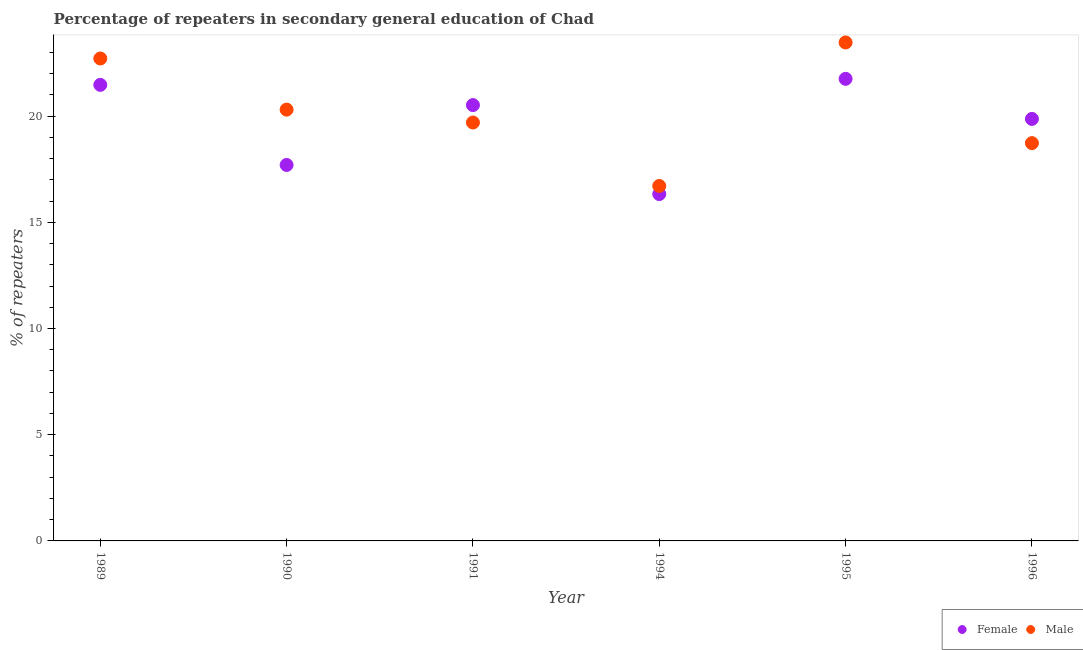How many different coloured dotlines are there?
Your answer should be very brief. 2. Is the number of dotlines equal to the number of legend labels?
Make the answer very short. Yes. What is the percentage of female repeaters in 1991?
Offer a terse response. 20.52. Across all years, what is the maximum percentage of male repeaters?
Your response must be concise. 23.47. Across all years, what is the minimum percentage of male repeaters?
Offer a terse response. 16.71. What is the total percentage of male repeaters in the graph?
Your response must be concise. 121.62. What is the difference between the percentage of female repeaters in 1990 and that in 1996?
Provide a succinct answer. -2.17. What is the difference between the percentage of female repeaters in 1989 and the percentage of male repeaters in 1990?
Provide a succinct answer. 1.17. What is the average percentage of male repeaters per year?
Your response must be concise. 20.27. In the year 1989, what is the difference between the percentage of female repeaters and percentage of male repeaters?
Keep it short and to the point. -1.24. What is the ratio of the percentage of male repeaters in 1990 to that in 1996?
Offer a terse response. 1.08. Is the percentage of male repeaters in 1989 less than that in 1994?
Give a very brief answer. No. What is the difference between the highest and the second highest percentage of female repeaters?
Make the answer very short. 0.28. What is the difference between the highest and the lowest percentage of female repeaters?
Your response must be concise. 5.42. Does the percentage of female repeaters monotonically increase over the years?
Make the answer very short. No. Is the percentage of female repeaters strictly less than the percentage of male repeaters over the years?
Ensure brevity in your answer.  No. How many years are there in the graph?
Offer a very short reply. 6. Are the values on the major ticks of Y-axis written in scientific E-notation?
Ensure brevity in your answer.  No. Where does the legend appear in the graph?
Keep it short and to the point. Bottom right. How are the legend labels stacked?
Ensure brevity in your answer.  Horizontal. What is the title of the graph?
Your answer should be compact. Percentage of repeaters in secondary general education of Chad. What is the label or title of the X-axis?
Your answer should be compact. Year. What is the label or title of the Y-axis?
Offer a terse response. % of repeaters. What is the % of repeaters in Female in 1989?
Your answer should be compact. 21.47. What is the % of repeaters in Male in 1989?
Keep it short and to the point. 22.71. What is the % of repeaters in Female in 1990?
Provide a succinct answer. 17.7. What is the % of repeaters of Male in 1990?
Keep it short and to the point. 20.3. What is the % of repeaters of Female in 1991?
Ensure brevity in your answer.  20.52. What is the % of repeaters of Male in 1991?
Offer a very short reply. 19.7. What is the % of repeaters in Female in 1994?
Provide a short and direct response. 16.33. What is the % of repeaters in Male in 1994?
Provide a short and direct response. 16.71. What is the % of repeaters in Female in 1995?
Offer a terse response. 21.75. What is the % of repeaters of Male in 1995?
Offer a very short reply. 23.47. What is the % of repeaters in Female in 1996?
Offer a terse response. 19.87. What is the % of repeaters in Male in 1996?
Give a very brief answer. 18.73. Across all years, what is the maximum % of repeaters of Female?
Your answer should be very brief. 21.75. Across all years, what is the maximum % of repeaters of Male?
Your answer should be compact. 23.47. Across all years, what is the minimum % of repeaters of Female?
Keep it short and to the point. 16.33. Across all years, what is the minimum % of repeaters in Male?
Make the answer very short. 16.71. What is the total % of repeaters of Female in the graph?
Offer a terse response. 117.64. What is the total % of repeaters in Male in the graph?
Make the answer very short. 121.62. What is the difference between the % of repeaters of Female in 1989 and that in 1990?
Your answer should be compact. 3.77. What is the difference between the % of repeaters of Male in 1989 and that in 1990?
Your answer should be compact. 2.41. What is the difference between the % of repeaters in Female in 1989 and that in 1991?
Offer a very short reply. 0.95. What is the difference between the % of repeaters of Male in 1989 and that in 1991?
Ensure brevity in your answer.  3.01. What is the difference between the % of repeaters of Female in 1989 and that in 1994?
Keep it short and to the point. 5.14. What is the difference between the % of repeaters of Male in 1989 and that in 1994?
Provide a succinct answer. 6. What is the difference between the % of repeaters of Female in 1989 and that in 1995?
Offer a terse response. -0.28. What is the difference between the % of repeaters in Male in 1989 and that in 1995?
Your answer should be compact. -0.76. What is the difference between the % of repeaters in Female in 1989 and that in 1996?
Keep it short and to the point. 1.6. What is the difference between the % of repeaters in Male in 1989 and that in 1996?
Provide a short and direct response. 3.98. What is the difference between the % of repeaters in Female in 1990 and that in 1991?
Give a very brief answer. -2.82. What is the difference between the % of repeaters of Male in 1990 and that in 1991?
Your response must be concise. 0.61. What is the difference between the % of repeaters of Female in 1990 and that in 1994?
Provide a succinct answer. 1.37. What is the difference between the % of repeaters of Male in 1990 and that in 1994?
Offer a terse response. 3.59. What is the difference between the % of repeaters of Female in 1990 and that in 1995?
Keep it short and to the point. -4.05. What is the difference between the % of repeaters of Male in 1990 and that in 1995?
Your answer should be compact. -3.16. What is the difference between the % of repeaters in Female in 1990 and that in 1996?
Make the answer very short. -2.17. What is the difference between the % of repeaters in Male in 1990 and that in 1996?
Make the answer very short. 1.58. What is the difference between the % of repeaters in Female in 1991 and that in 1994?
Offer a terse response. 4.19. What is the difference between the % of repeaters of Male in 1991 and that in 1994?
Your answer should be very brief. 2.99. What is the difference between the % of repeaters of Female in 1991 and that in 1995?
Your answer should be very brief. -1.24. What is the difference between the % of repeaters in Male in 1991 and that in 1995?
Keep it short and to the point. -3.77. What is the difference between the % of repeaters in Female in 1991 and that in 1996?
Offer a very short reply. 0.65. What is the difference between the % of repeaters in Female in 1994 and that in 1995?
Provide a short and direct response. -5.42. What is the difference between the % of repeaters of Male in 1994 and that in 1995?
Provide a succinct answer. -6.76. What is the difference between the % of repeaters in Female in 1994 and that in 1996?
Provide a short and direct response. -3.54. What is the difference between the % of repeaters in Male in 1994 and that in 1996?
Provide a short and direct response. -2.02. What is the difference between the % of repeaters in Female in 1995 and that in 1996?
Make the answer very short. 1.89. What is the difference between the % of repeaters in Male in 1995 and that in 1996?
Provide a short and direct response. 4.74. What is the difference between the % of repeaters of Female in 1989 and the % of repeaters of Male in 1990?
Your answer should be compact. 1.17. What is the difference between the % of repeaters of Female in 1989 and the % of repeaters of Male in 1991?
Offer a very short reply. 1.77. What is the difference between the % of repeaters of Female in 1989 and the % of repeaters of Male in 1994?
Make the answer very short. 4.76. What is the difference between the % of repeaters in Female in 1989 and the % of repeaters in Male in 1995?
Ensure brevity in your answer.  -2. What is the difference between the % of repeaters of Female in 1989 and the % of repeaters of Male in 1996?
Offer a terse response. 2.74. What is the difference between the % of repeaters of Female in 1990 and the % of repeaters of Male in 1991?
Make the answer very short. -2. What is the difference between the % of repeaters of Female in 1990 and the % of repeaters of Male in 1994?
Ensure brevity in your answer.  0.99. What is the difference between the % of repeaters of Female in 1990 and the % of repeaters of Male in 1995?
Your response must be concise. -5.77. What is the difference between the % of repeaters of Female in 1990 and the % of repeaters of Male in 1996?
Provide a short and direct response. -1.03. What is the difference between the % of repeaters in Female in 1991 and the % of repeaters in Male in 1994?
Your response must be concise. 3.81. What is the difference between the % of repeaters in Female in 1991 and the % of repeaters in Male in 1995?
Provide a short and direct response. -2.95. What is the difference between the % of repeaters of Female in 1991 and the % of repeaters of Male in 1996?
Ensure brevity in your answer.  1.79. What is the difference between the % of repeaters of Female in 1994 and the % of repeaters of Male in 1995?
Give a very brief answer. -7.14. What is the difference between the % of repeaters of Female in 1994 and the % of repeaters of Male in 1996?
Ensure brevity in your answer.  -2.4. What is the difference between the % of repeaters of Female in 1995 and the % of repeaters of Male in 1996?
Offer a terse response. 3.03. What is the average % of repeaters in Female per year?
Your answer should be compact. 19.61. What is the average % of repeaters of Male per year?
Keep it short and to the point. 20.27. In the year 1989, what is the difference between the % of repeaters in Female and % of repeaters in Male?
Your response must be concise. -1.24. In the year 1990, what is the difference between the % of repeaters of Female and % of repeaters of Male?
Provide a succinct answer. -2.6. In the year 1991, what is the difference between the % of repeaters of Female and % of repeaters of Male?
Offer a terse response. 0.82. In the year 1994, what is the difference between the % of repeaters of Female and % of repeaters of Male?
Give a very brief answer. -0.38. In the year 1995, what is the difference between the % of repeaters in Female and % of repeaters in Male?
Give a very brief answer. -1.71. In the year 1996, what is the difference between the % of repeaters of Female and % of repeaters of Male?
Your answer should be very brief. 1.14. What is the ratio of the % of repeaters in Female in 1989 to that in 1990?
Keep it short and to the point. 1.21. What is the ratio of the % of repeaters in Male in 1989 to that in 1990?
Ensure brevity in your answer.  1.12. What is the ratio of the % of repeaters of Female in 1989 to that in 1991?
Make the answer very short. 1.05. What is the ratio of the % of repeaters in Male in 1989 to that in 1991?
Provide a short and direct response. 1.15. What is the ratio of the % of repeaters in Female in 1989 to that in 1994?
Give a very brief answer. 1.31. What is the ratio of the % of repeaters in Male in 1989 to that in 1994?
Offer a terse response. 1.36. What is the ratio of the % of repeaters in Female in 1989 to that in 1995?
Provide a short and direct response. 0.99. What is the ratio of the % of repeaters in Male in 1989 to that in 1995?
Make the answer very short. 0.97. What is the ratio of the % of repeaters of Female in 1989 to that in 1996?
Provide a succinct answer. 1.08. What is the ratio of the % of repeaters in Male in 1989 to that in 1996?
Provide a succinct answer. 1.21. What is the ratio of the % of repeaters in Female in 1990 to that in 1991?
Offer a terse response. 0.86. What is the ratio of the % of repeaters in Male in 1990 to that in 1991?
Provide a short and direct response. 1.03. What is the ratio of the % of repeaters of Female in 1990 to that in 1994?
Offer a very short reply. 1.08. What is the ratio of the % of repeaters of Male in 1990 to that in 1994?
Keep it short and to the point. 1.22. What is the ratio of the % of repeaters in Female in 1990 to that in 1995?
Keep it short and to the point. 0.81. What is the ratio of the % of repeaters of Male in 1990 to that in 1995?
Offer a terse response. 0.87. What is the ratio of the % of repeaters in Female in 1990 to that in 1996?
Provide a succinct answer. 0.89. What is the ratio of the % of repeaters in Male in 1990 to that in 1996?
Your answer should be compact. 1.08. What is the ratio of the % of repeaters in Female in 1991 to that in 1994?
Make the answer very short. 1.26. What is the ratio of the % of repeaters in Male in 1991 to that in 1994?
Provide a succinct answer. 1.18. What is the ratio of the % of repeaters of Female in 1991 to that in 1995?
Offer a very short reply. 0.94. What is the ratio of the % of repeaters in Male in 1991 to that in 1995?
Your answer should be compact. 0.84. What is the ratio of the % of repeaters in Female in 1991 to that in 1996?
Your response must be concise. 1.03. What is the ratio of the % of repeaters in Male in 1991 to that in 1996?
Offer a terse response. 1.05. What is the ratio of the % of repeaters in Female in 1994 to that in 1995?
Your response must be concise. 0.75. What is the ratio of the % of repeaters in Male in 1994 to that in 1995?
Keep it short and to the point. 0.71. What is the ratio of the % of repeaters of Female in 1994 to that in 1996?
Provide a succinct answer. 0.82. What is the ratio of the % of repeaters of Male in 1994 to that in 1996?
Offer a terse response. 0.89. What is the ratio of the % of repeaters of Female in 1995 to that in 1996?
Provide a short and direct response. 1.09. What is the ratio of the % of repeaters of Male in 1995 to that in 1996?
Provide a short and direct response. 1.25. What is the difference between the highest and the second highest % of repeaters of Female?
Provide a short and direct response. 0.28. What is the difference between the highest and the second highest % of repeaters of Male?
Your answer should be very brief. 0.76. What is the difference between the highest and the lowest % of repeaters in Female?
Make the answer very short. 5.42. What is the difference between the highest and the lowest % of repeaters in Male?
Keep it short and to the point. 6.76. 